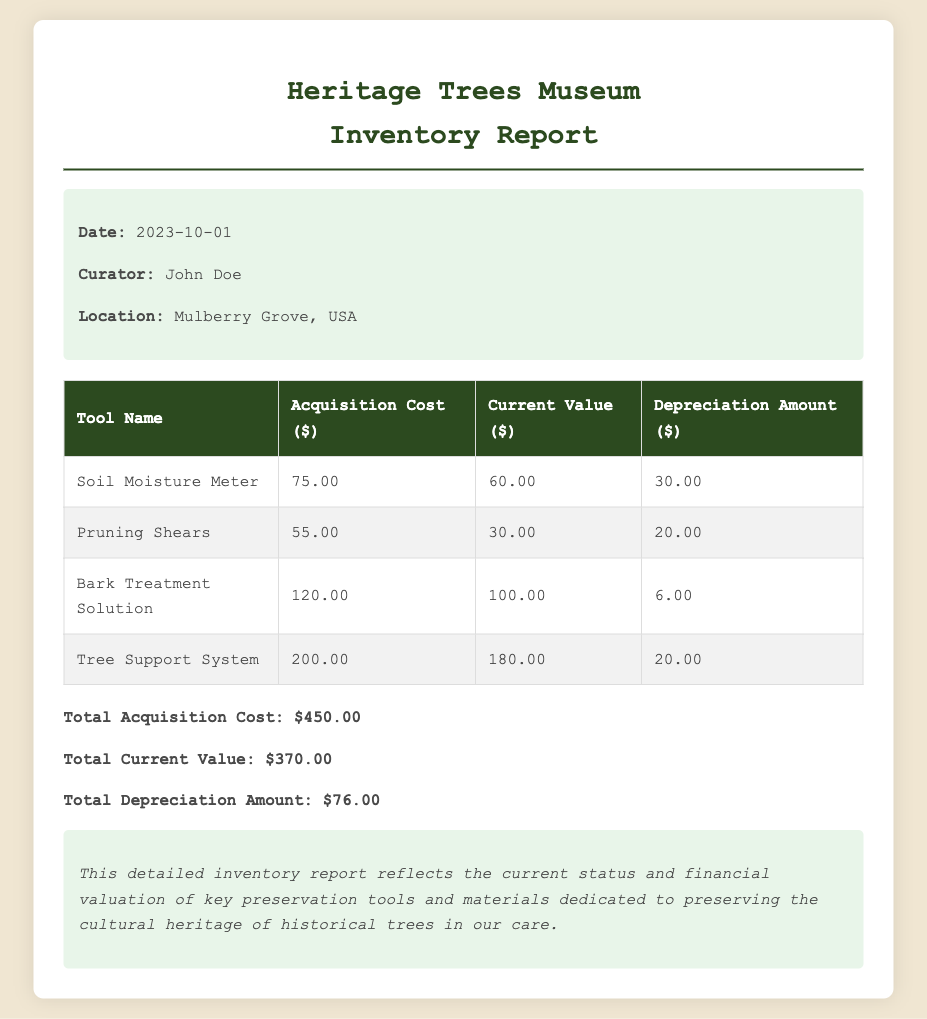What is the date of the report? The report date is mentioned clearly in the report info section.
Answer: 2023-10-01 Who is the curator mentioned in the report? The curator's name is provided in the report info section.
Answer: John Doe What is the total acquisition cost listed? The total acquisition cost is found in the totals section of the document.
Answer: $450.00 What is the current value of the preservation tools and materials? The current value is stated in the totals section of the report.
Answer: $370.00 Which tool has the highest depreciation amount? To find the highest depreciation amount, we look through the depreciation amounts listed.
Answer: Soil Moisture Meter What is the acquisition cost of the Bark Treatment Solution? The acquisition cost can be found in the table under the corresponding tool.
Answer: $120.00 What is the total depreciation amount for all tools? This is calculated by summing up all the depreciation amounts listed in the document.
Answer: $76.00 Which tool has the lowest current value? The tool with the lowest current value can be determined from the values listed in the table.
Answer: Pruning Shears What background color is used for the report section? The background color used for the report section is described in the document's style.
Answer: #f0e6d2 